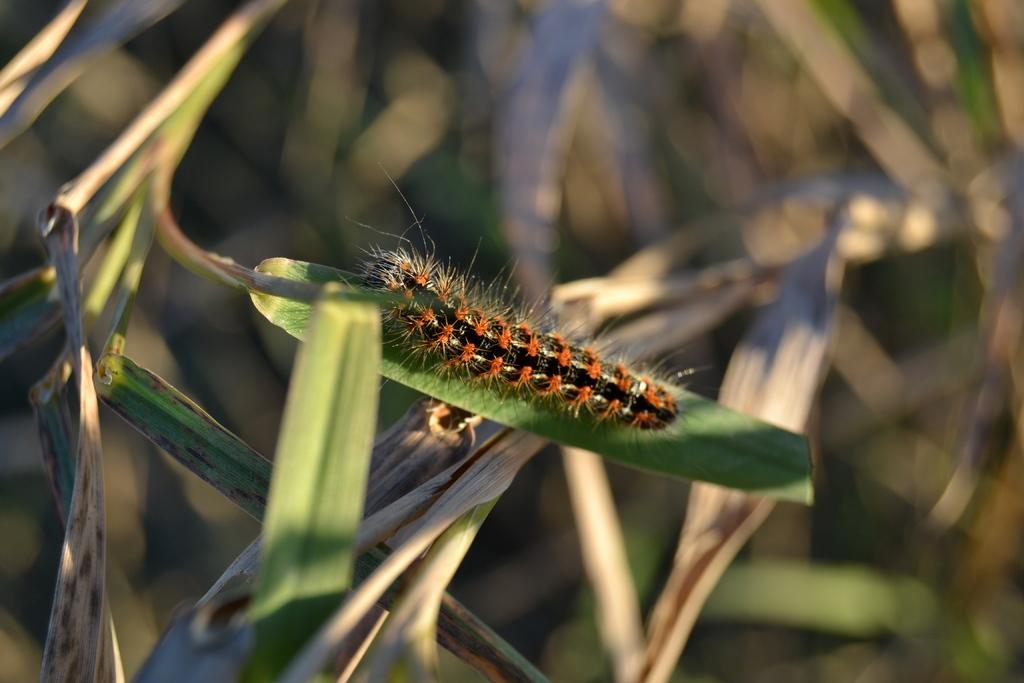What is the main subject of the image? There is a caterpillar on a leaf in the image. What else can be seen on the plant in the image? There are leaves on the plant in the image. How would you describe the background of the image? The background of the image is blurred. What type of lock can be seen securing the observation deck in the image? There is no lock or observation deck present in the image; it features a caterpillar on a leaf with blurred background. 